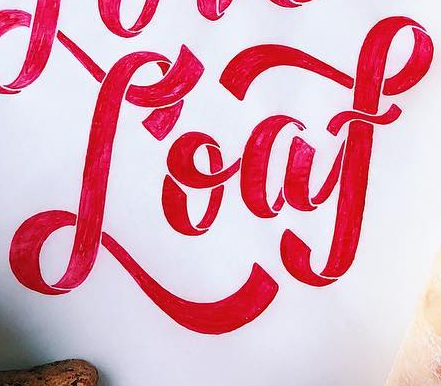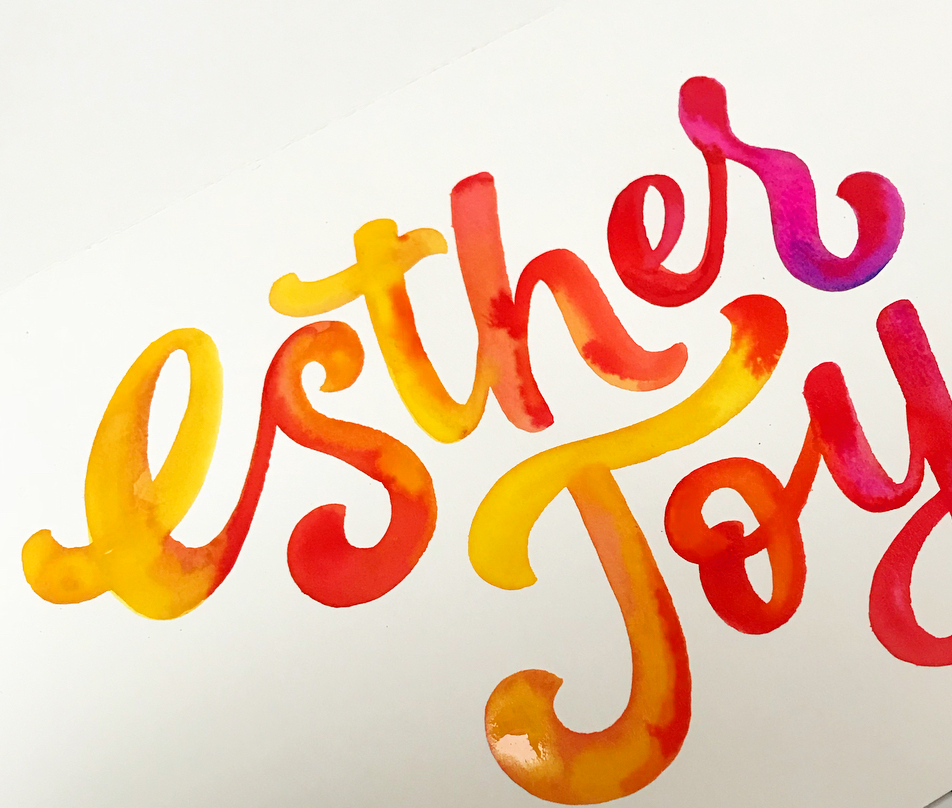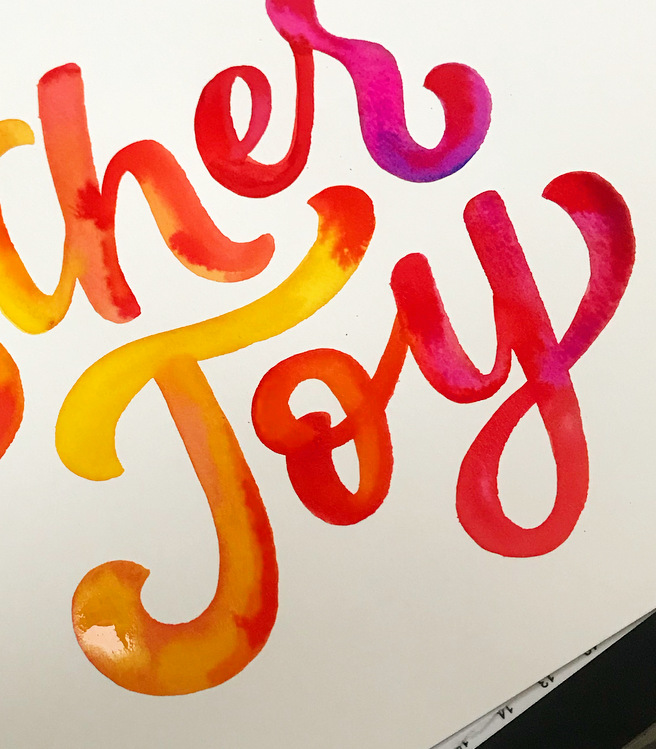Transcribe the words shown in these images in order, separated by a semicolon. Loaf; Esthes; Joy 